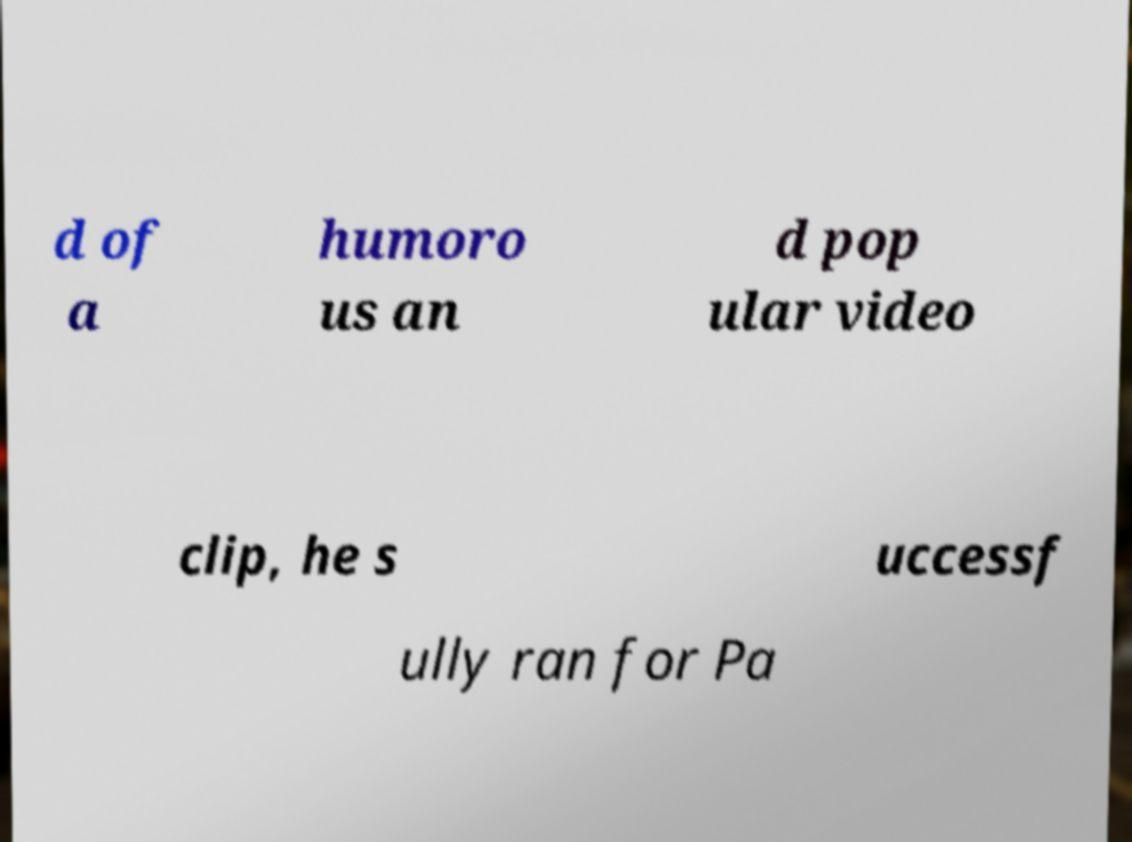For documentation purposes, I need the text within this image transcribed. Could you provide that? d of a humoro us an d pop ular video clip, he s uccessf ully ran for Pa 